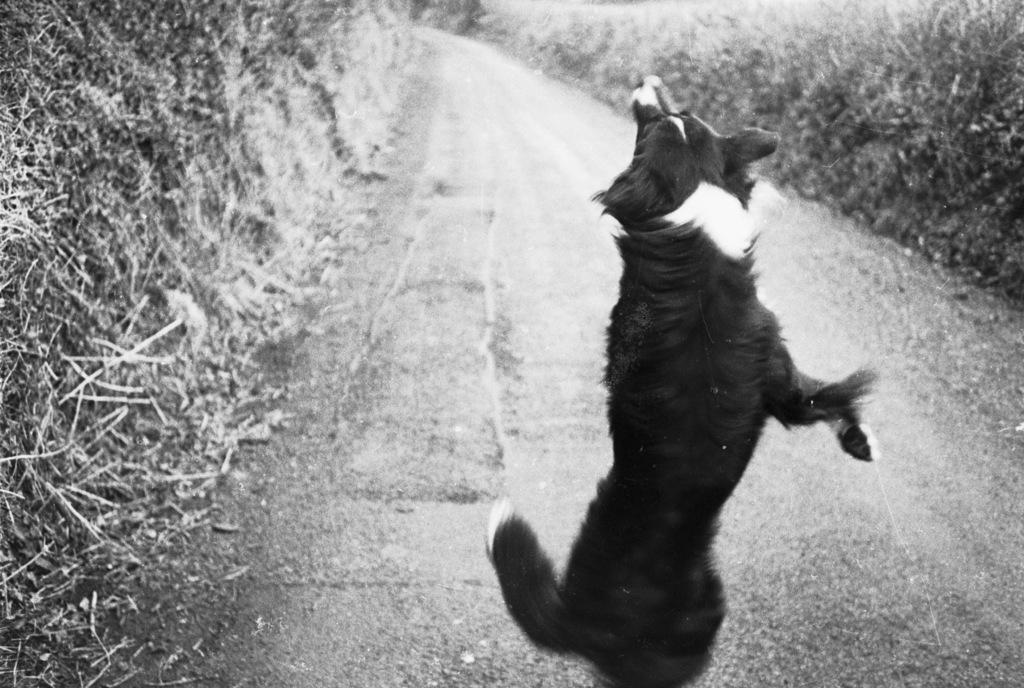What animal can be seen on the road in the image? There is a dog present on the road in the image. Where is the dog located in the image? The dog is in the middle of the image. What type of environment is visible in the background of the image? There appears to be greenery in the background of the image. Can you tell me which queen is standing next to the dog in the image? There is no queen present in the image; it only features a dog on the road. What type of line can be seen connecting the dog to the greenery in the background? There is no line connecting the dog to the greenery in the image; the dog is simply located on the road with greenery visible in the background. 